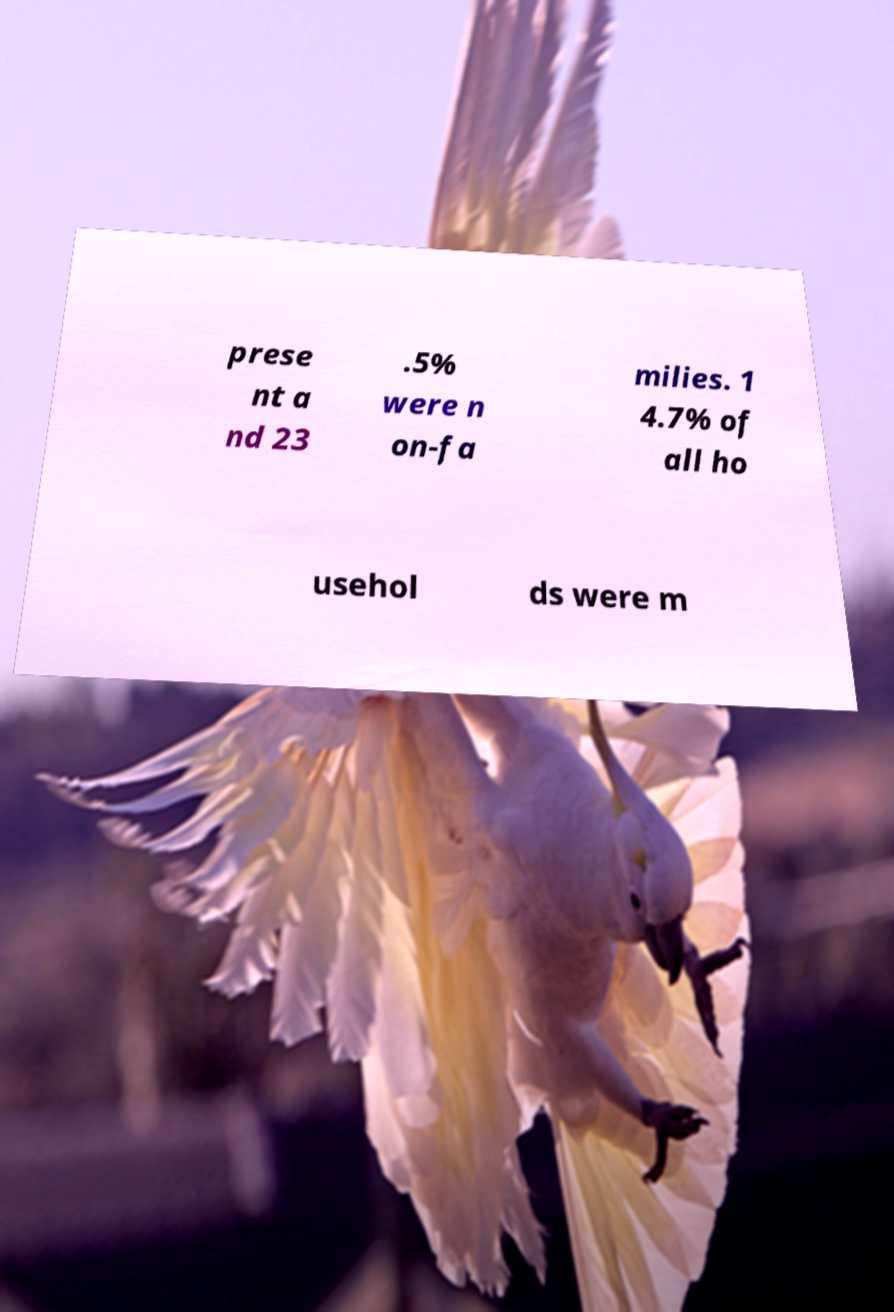I need the written content from this picture converted into text. Can you do that? prese nt a nd 23 .5% were n on-fa milies. 1 4.7% of all ho usehol ds were m 